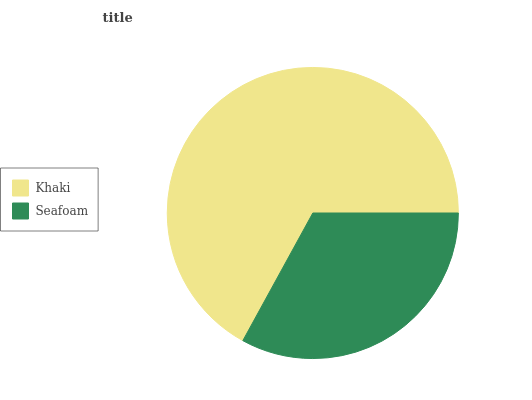Is Seafoam the minimum?
Answer yes or no. Yes. Is Khaki the maximum?
Answer yes or no. Yes. Is Seafoam the maximum?
Answer yes or no. No. Is Khaki greater than Seafoam?
Answer yes or no. Yes. Is Seafoam less than Khaki?
Answer yes or no. Yes. Is Seafoam greater than Khaki?
Answer yes or no. No. Is Khaki less than Seafoam?
Answer yes or no. No. Is Khaki the high median?
Answer yes or no. Yes. Is Seafoam the low median?
Answer yes or no. Yes. Is Seafoam the high median?
Answer yes or no. No. Is Khaki the low median?
Answer yes or no. No. 